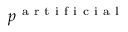<formula> <loc_0><loc_0><loc_500><loc_500>p ^ { a r t i f i c i a l }</formula> 